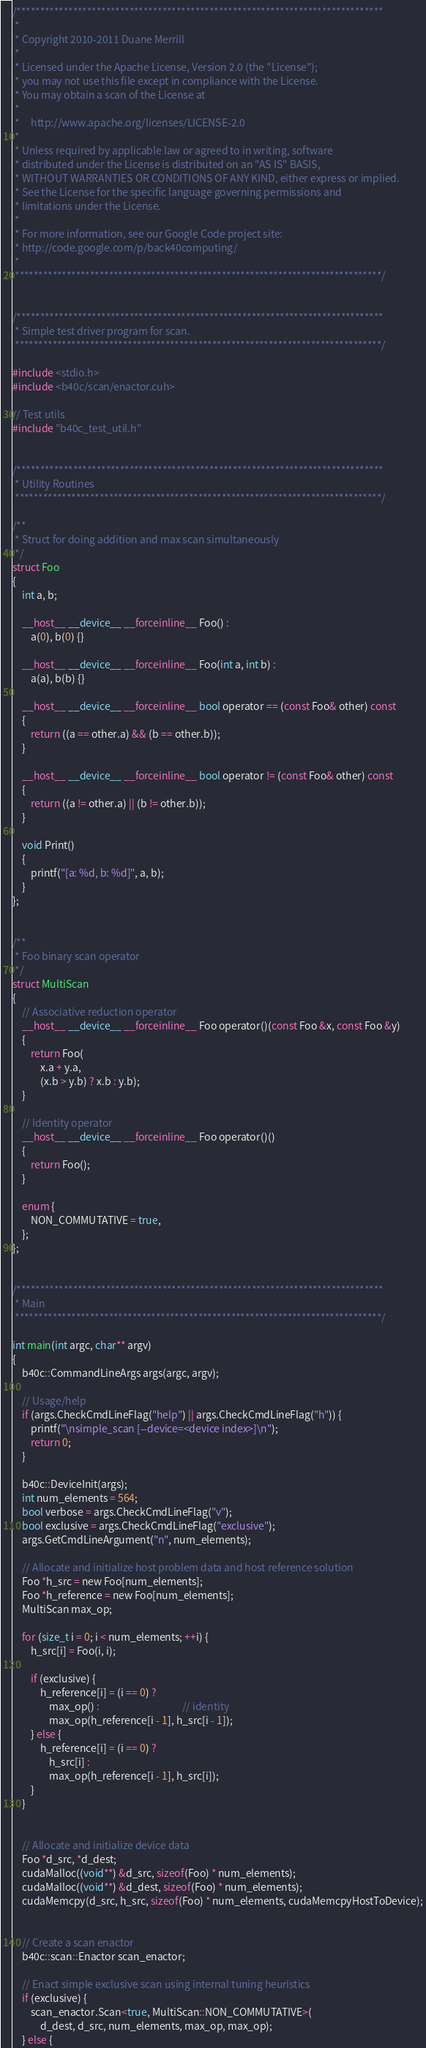Convert code to text. <code><loc_0><loc_0><loc_500><loc_500><_Cuda_>/******************************************************************************
 * 
 * Copyright 2010-2011 Duane Merrill
 *
 * Licensed under the Apache License, Version 2.0 (the "License");
 * you may not use this file except in compliance with the License.
 * You may obtain a scan of the License at
 * 
 *     http://www.apache.org/licenses/LICENSE-2.0
 *
 * Unless required by applicable law or agreed to in writing, software
 * distributed under the License is distributed on an "AS IS" BASIS,
 * WITHOUT WARRANTIES OR CONDITIONS OF ANY KIND, either express or implied.
 * See the License for the specific language governing permissions and
 * limitations under the License. 
 * 
 * For more information, see our Google Code project site: 
 * http://code.google.com/p/back40computing/
 * 
 ******************************************************************************/


/******************************************************************************
 * Simple test driver program for scan.
 ******************************************************************************/

#include <stdio.h> 
#include <b40c/scan/enactor.cuh>

// Test utils
#include "b40c_test_util.h"


/******************************************************************************
 * Utility Routines
 ******************************************************************************/

/**
 * Struct for doing addition and max scan simultaneously
 */
struct Foo
{
	int a, b;

	__host__ __device__ __forceinline__ Foo() :
		a(0), b(0) {}

	__host__ __device__ __forceinline__ Foo(int a, int b) :
		a(a), b(b) {}

	__host__ __device__ __forceinline__ bool operator == (const Foo& other) const
	{
		return ((a == other.a) && (b == other.b));
	}

	__host__ __device__ __forceinline__ bool operator != (const Foo& other) const
	{
		return ((a != other.a) || (b != other.b));
	}

	void Print()
	{
		printf("[a: %d, b: %d]", a, b);
	}
};


/**
 * Foo binary scan operator
 */
struct MultiScan
{
	// Associative reduction operator
	__host__ __device__ __forceinline__ Foo operator()(const Foo &x, const Foo &y)
	{
		return Foo(
			x.a + y.a,
			(x.b > y.b) ? x.b : y.b);
	}

	// Identity operator
	__host__ __device__ __forceinline__ Foo operator()()
	{
		return Foo();
	}

	enum {
		NON_COMMUTATIVE = true,
	};
};


/******************************************************************************
 * Main
 ******************************************************************************/

int main(int argc, char** argv)
{
	b40c::CommandLineArgs args(argc, argv);

	// Usage/help
    if (args.CheckCmdLineFlag("help") || args.CheckCmdLineFlag("h")) {
    	printf("\nsimple_scan [--device=<device index>]\n");
    	return 0;
    }

    b40c::DeviceInit(args);
    int num_elements = 564;
    bool verbose = args.CheckCmdLineFlag("v");
    bool exclusive = args.CheckCmdLineFlag("exclusive");
    args.GetCmdLineArgument("n", num_elements);

	// Allocate and initialize host problem data and host reference solution
	Foo *h_src = new Foo[num_elements];
	Foo *h_reference = new Foo[num_elements];
	MultiScan max_op;

	for (size_t i = 0; i < num_elements; ++i) {
		h_src[i] = Foo(i, i);

		if (exclusive) {
			h_reference[i] = (i == 0) ?
				max_op() :									// identity
				max_op(h_reference[i - 1], h_src[i - 1]);
		} else {
			h_reference[i] = (i == 0) ?
				h_src[i] :
				max_op(h_reference[i - 1], h_src[i]);
		}
	}

	
	// Allocate and initialize device data
	Foo *d_src, *d_dest;
	cudaMalloc((void**) &d_src, sizeof(Foo) * num_elements);
	cudaMalloc((void**) &d_dest, sizeof(Foo) * num_elements);
	cudaMemcpy(d_src, h_src, sizeof(Foo) * num_elements, cudaMemcpyHostToDevice);


	// Create a scan enactor
	b40c::scan::Enactor scan_enactor;

	// Enact simple exclusive scan using internal tuning heuristics
	if (exclusive) {
		scan_enactor.Scan<true, MultiScan::NON_COMMUTATIVE>(
			d_dest, d_src, num_elements, max_op, max_op);
	} else {</code> 